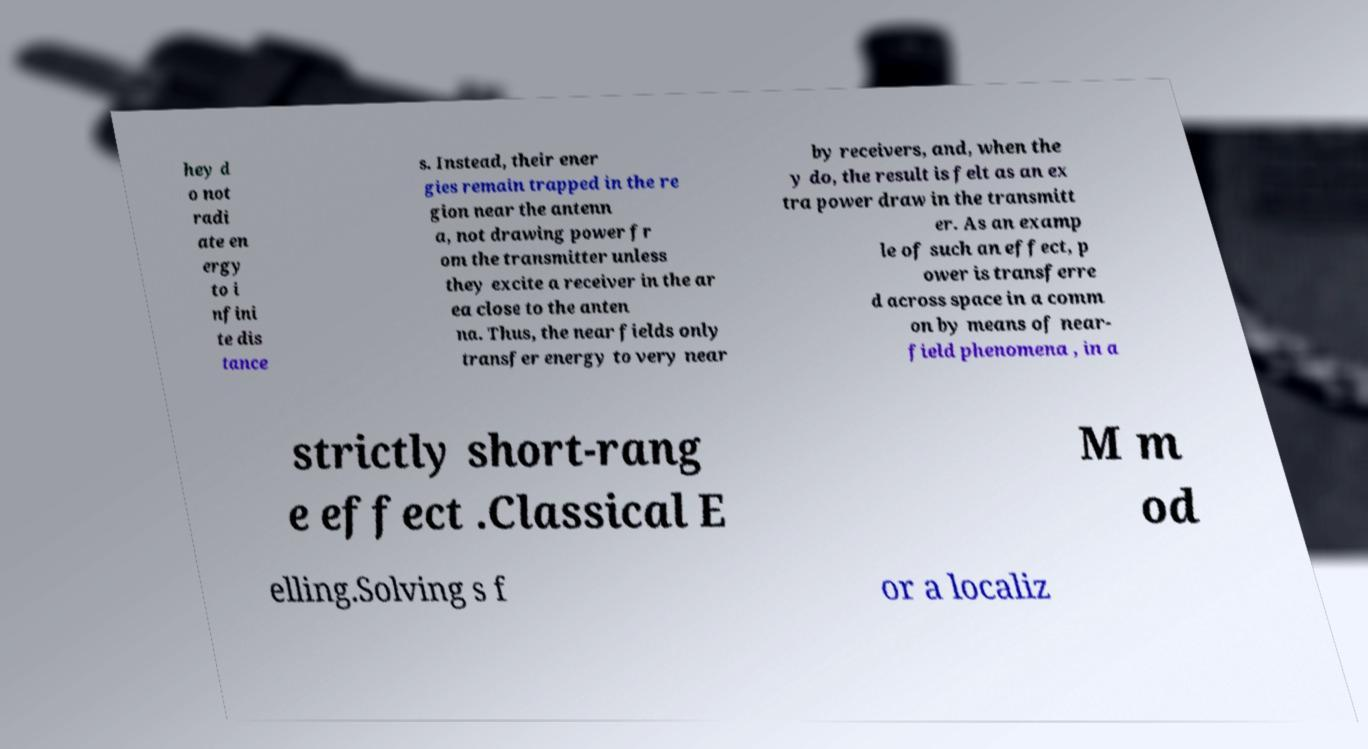There's text embedded in this image that I need extracted. Can you transcribe it verbatim? hey d o not radi ate en ergy to i nfini te dis tance s. Instead, their ener gies remain trapped in the re gion near the antenn a, not drawing power fr om the transmitter unless they excite a receiver in the ar ea close to the anten na. Thus, the near fields only transfer energy to very near by receivers, and, when the y do, the result is felt as an ex tra power draw in the transmitt er. As an examp le of such an effect, p ower is transferre d across space in a comm on by means of near- field phenomena , in a strictly short-rang e effect .Classical E M m od elling.Solving s f or a localiz 